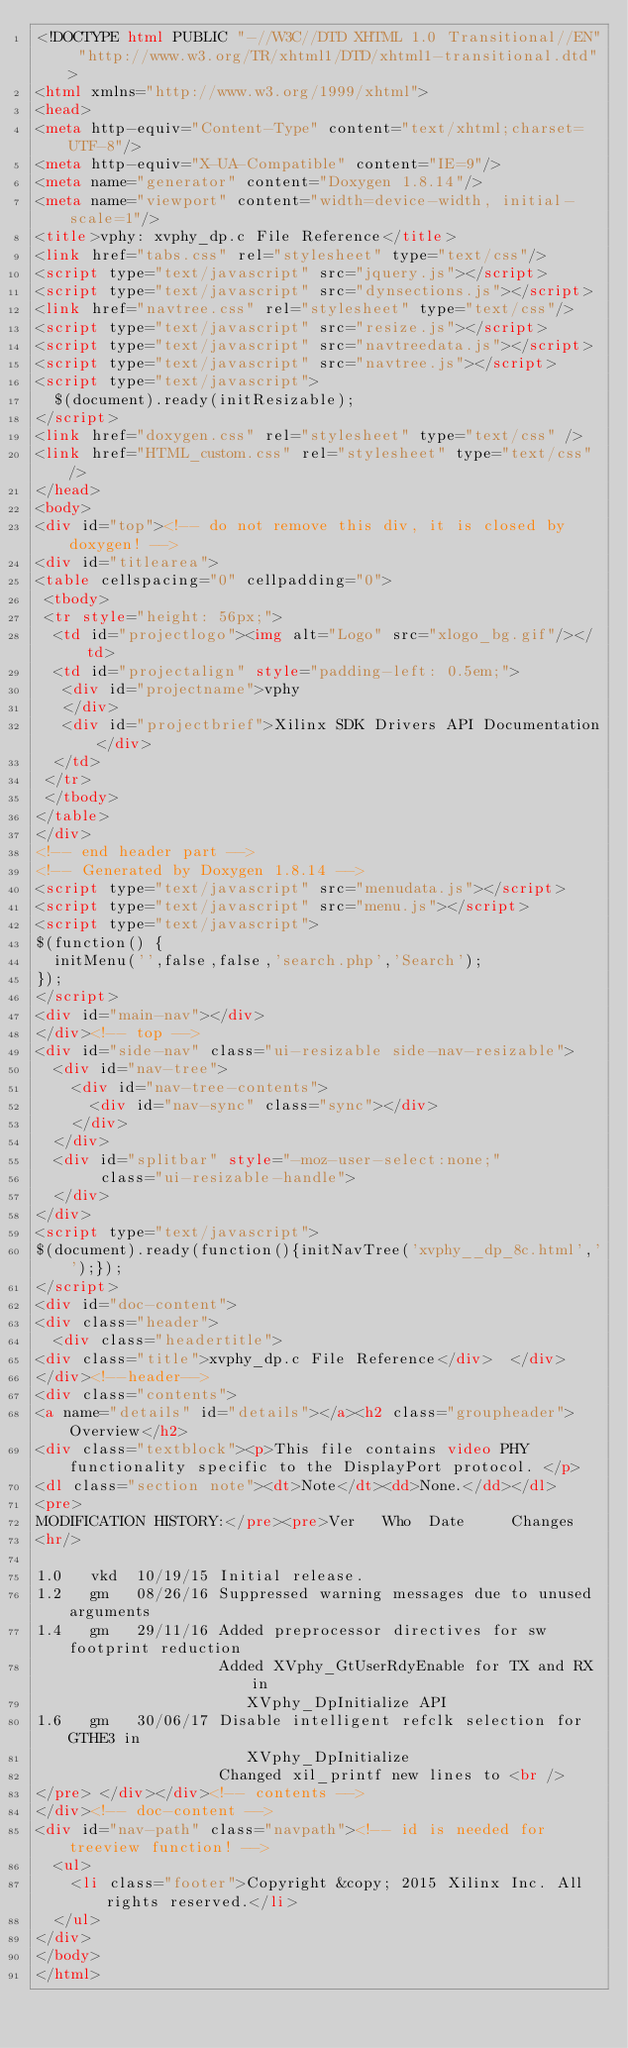<code> <loc_0><loc_0><loc_500><loc_500><_HTML_><!DOCTYPE html PUBLIC "-//W3C//DTD XHTML 1.0 Transitional//EN" "http://www.w3.org/TR/xhtml1/DTD/xhtml1-transitional.dtd">
<html xmlns="http://www.w3.org/1999/xhtml">
<head>
<meta http-equiv="Content-Type" content="text/xhtml;charset=UTF-8"/>
<meta http-equiv="X-UA-Compatible" content="IE=9"/>
<meta name="generator" content="Doxygen 1.8.14"/>
<meta name="viewport" content="width=device-width, initial-scale=1"/>
<title>vphy: xvphy_dp.c File Reference</title>
<link href="tabs.css" rel="stylesheet" type="text/css"/>
<script type="text/javascript" src="jquery.js"></script>
<script type="text/javascript" src="dynsections.js"></script>
<link href="navtree.css" rel="stylesheet" type="text/css"/>
<script type="text/javascript" src="resize.js"></script>
<script type="text/javascript" src="navtreedata.js"></script>
<script type="text/javascript" src="navtree.js"></script>
<script type="text/javascript">
  $(document).ready(initResizable);
</script>
<link href="doxygen.css" rel="stylesheet" type="text/css" />
<link href="HTML_custom.css" rel="stylesheet" type="text/css"/>
</head>
<body>
<div id="top"><!-- do not remove this div, it is closed by doxygen! -->
<div id="titlearea">
<table cellspacing="0" cellpadding="0">
 <tbody>
 <tr style="height: 56px;">
  <td id="projectlogo"><img alt="Logo" src="xlogo_bg.gif"/></td>
  <td id="projectalign" style="padding-left: 0.5em;">
   <div id="projectname">vphy
   </div>
   <div id="projectbrief">Xilinx SDK Drivers API Documentation</div>
  </td>
 </tr>
 </tbody>
</table>
</div>
<!-- end header part -->
<!-- Generated by Doxygen 1.8.14 -->
<script type="text/javascript" src="menudata.js"></script>
<script type="text/javascript" src="menu.js"></script>
<script type="text/javascript">
$(function() {
  initMenu('',false,false,'search.php','Search');
});
</script>
<div id="main-nav"></div>
</div><!-- top -->
<div id="side-nav" class="ui-resizable side-nav-resizable">
  <div id="nav-tree">
    <div id="nav-tree-contents">
      <div id="nav-sync" class="sync"></div>
    </div>
  </div>
  <div id="splitbar" style="-moz-user-select:none;" 
       class="ui-resizable-handle">
  </div>
</div>
<script type="text/javascript">
$(document).ready(function(){initNavTree('xvphy__dp_8c.html','');});
</script>
<div id="doc-content">
<div class="header">
  <div class="headertitle">
<div class="title">xvphy_dp.c File Reference</div>  </div>
</div><!--header-->
<div class="contents">
<a name="details" id="details"></a><h2 class="groupheader">Overview</h2>
<div class="textblock"><p>This file contains video PHY functionality specific to the DisplayPort protocol. </p>
<dl class="section note"><dt>Note</dt><dd>None.</dd></dl>
<pre>
MODIFICATION HISTORY:</pre><pre>Ver   Who  Date     Changes
<hr/>

1.0   vkd  10/19/15 Initial release.
1.2   gm   08/26/16 Suppressed warning messages due to unused arguments
1.4   gm   29/11/16 Added preprocessor directives for sw footprint reduction
                    Added XVphy_GtUserRdyEnable for TX and RX in
                       XVphy_DpInitialize API
1.6   gm   30/06/17 Disable intelligent refclk selection for GTHE3 in
                       XVphy_DpInitialize
                    Changed xil_printf new lines to <br />
</pre> </div></div><!-- contents -->
</div><!-- doc-content -->
<div id="nav-path" class="navpath"><!-- id is needed for treeview function! -->
  <ul>
    <li class="footer">Copyright &copy; 2015 Xilinx Inc. All rights reserved.</li>
  </ul>
</div>
</body>
</html>
</code> 